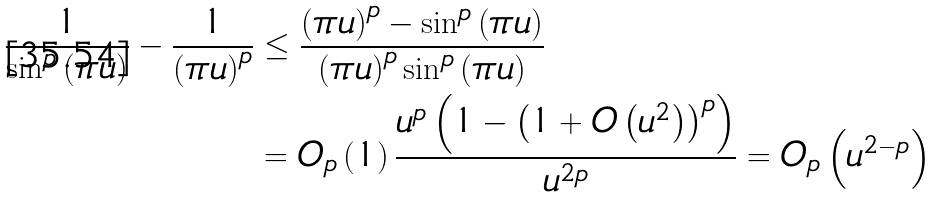<formula> <loc_0><loc_0><loc_500><loc_500>\frac { 1 } { \sin ^ { p } \left ( \pi u \right ) } - \frac { 1 } { \left ( \pi u \right ) ^ { p } } & \leq \frac { \left ( \pi u \right ) ^ { p } - \sin ^ { p } \left ( \pi u \right ) } { \left ( \pi u \right ) ^ { p } \sin ^ { p } \left ( \pi u \right ) } \\ & = O _ { p } \left ( 1 \right ) \frac { u ^ { p } \left ( 1 - \left ( 1 + O \left ( u ^ { 2 } \right ) \right ) ^ { p } \right ) } { u ^ { 2 p } } = O _ { p } \left ( u ^ { 2 - p } \right )</formula> 